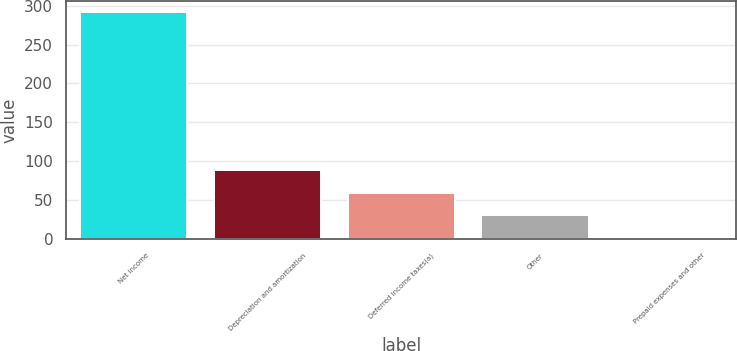Convert chart. <chart><loc_0><loc_0><loc_500><loc_500><bar_chart><fcel>Net income<fcel>Depreciation and amortization<fcel>Deferred income taxes(a)<fcel>Other<fcel>Prepaid expenses and other<nl><fcel>291.5<fcel>88.57<fcel>59.58<fcel>30.59<fcel>1.6<nl></chart> 